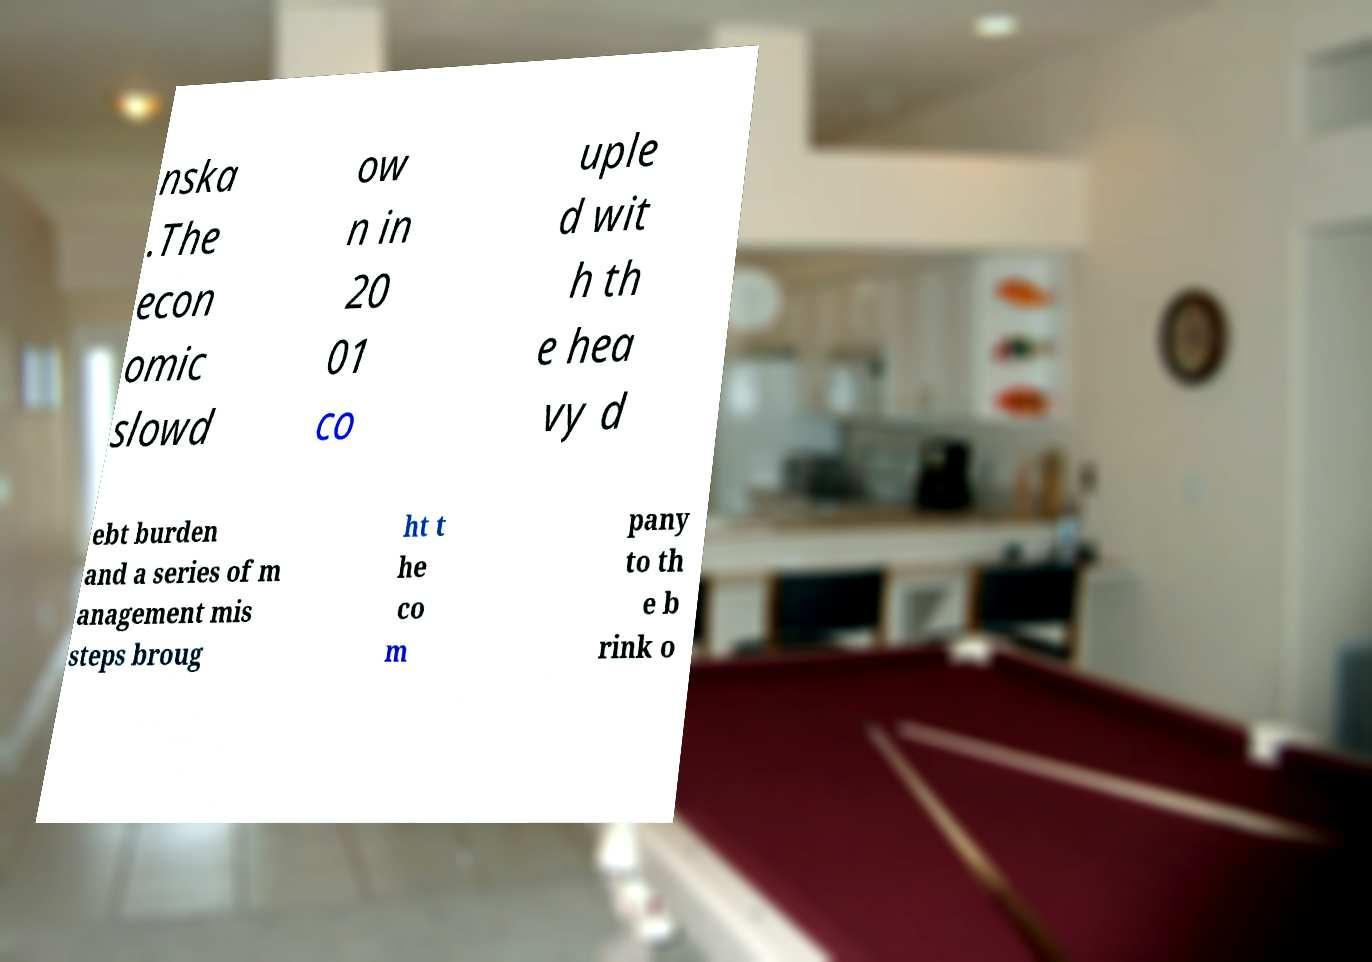There's text embedded in this image that I need extracted. Can you transcribe it verbatim? nska .The econ omic slowd ow n in 20 01 co uple d wit h th e hea vy d ebt burden and a series of m anagement mis steps broug ht t he co m pany to th e b rink o 